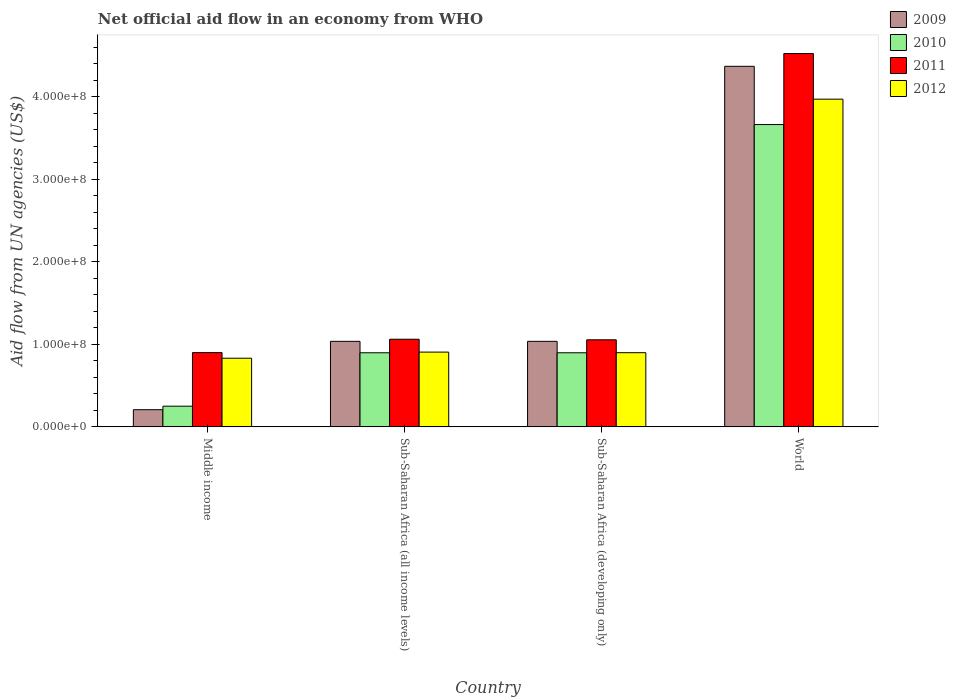How many different coloured bars are there?
Ensure brevity in your answer.  4. How many groups of bars are there?
Offer a terse response. 4. Are the number of bars per tick equal to the number of legend labels?
Provide a short and direct response. Yes. In how many cases, is the number of bars for a given country not equal to the number of legend labels?
Ensure brevity in your answer.  0. What is the net official aid flow in 2011 in Sub-Saharan Africa (developing only)?
Your answer should be compact. 1.05e+08. Across all countries, what is the maximum net official aid flow in 2010?
Your response must be concise. 3.66e+08. Across all countries, what is the minimum net official aid flow in 2011?
Your response must be concise. 9.00e+07. In which country was the net official aid flow in 2009 maximum?
Your response must be concise. World. What is the total net official aid flow in 2011 in the graph?
Make the answer very short. 7.54e+08. What is the difference between the net official aid flow in 2010 in Sub-Saharan Africa (all income levels) and that in World?
Keep it short and to the point. -2.76e+08. What is the difference between the net official aid flow in 2010 in World and the net official aid flow in 2011 in Sub-Saharan Africa (all income levels)?
Your answer should be very brief. 2.60e+08. What is the average net official aid flow in 2011 per country?
Your answer should be compact. 1.88e+08. What is the difference between the net official aid flow of/in 2010 and net official aid flow of/in 2011 in Sub-Saharan Africa (developing only)?
Offer a terse response. -1.57e+07. What is the ratio of the net official aid flow in 2012 in Middle income to that in Sub-Saharan Africa (all income levels)?
Your answer should be compact. 0.92. What is the difference between the highest and the second highest net official aid flow in 2011?
Your response must be concise. 3.47e+08. What is the difference between the highest and the lowest net official aid flow in 2010?
Provide a short and direct response. 3.41e+08. In how many countries, is the net official aid flow in 2011 greater than the average net official aid flow in 2011 taken over all countries?
Your response must be concise. 1. Is it the case that in every country, the sum of the net official aid flow in 2012 and net official aid flow in 2009 is greater than the sum of net official aid flow in 2010 and net official aid flow in 2011?
Ensure brevity in your answer.  No. What does the 4th bar from the left in World represents?
Give a very brief answer. 2012. Is it the case that in every country, the sum of the net official aid flow in 2009 and net official aid flow in 2011 is greater than the net official aid flow in 2010?
Give a very brief answer. Yes. How many countries are there in the graph?
Make the answer very short. 4. Are the values on the major ticks of Y-axis written in scientific E-notation?
Make the answer very short. Yes. Does the graph contain any zero values?
Keep it short and to the point. No. Does the graph contain grids?
Provide a short and direct response. No. Where does the legend appear in the graph?
Your answer should be very brief. Top right. What is the title of the graph?
Offer a terse response. Net official aid flow in an economy from WHO. What is the label or title of the Y-axis?
Provide a succinct answer. Aid flow from UN agencies (US$). What is the Aid flow from UN agencies (US$) in 2009 in Middle income?
Offer a very short reply. 2.08e+07. What is the Aid flow from UN agencies (US$) of 2010 in Middle income?
Offer a very short reply. 2.51e+07. What is the Aid flow from UN agencies (US$) of 2011 in Middle income?
Provide a short and direct response. 9.00e+07. What is the Aid flow from UN agencies (US$) of 2012 in Middle income?
Your answer should be compact. 8.32e+07. What is the Aid flow from UN agencies (US$) in 2009 in Sub-Saharan Africa (all income levels)?
Offer a very short reply. 1.04e+08. What is the Aid flow from UN agencies (US$) in 2010 in Sub-Saharan Africa (all income levels)?
Keep it short and to the point. 8.98e+07. What is the Aid flow from UN agencies (US$) in 2011 in Sub-Saharan Africa (all income levels)?
Provide a short and direct response. 1.06e+08. What is the Aid flow from UN agencies (US$) in 2012 in Sub-Saharan Africa (all income levels)?
Offer a very short reply. 9.06e+07. What is the Aid flow from UN agencies (US$) of 2009 in Sub-Saharan Africa (developing only)?
Provide a short and direct response. 1.04e+08. What is the Aid flow from UN agencies (US$) of 2010 in Sub-Saharan Africa (developing only)?
Your answer should be compact. 8.98e+07. What is the Aid flow from UN agencies (US$) of 2011 in Sub-Saharan Africa (developing only)?
Provide a short and direct response. 1.05e+08. What is the Aid flow from UN agencies (US$) in 2012 in Sub-Saharan Africa (developing only)?
Your response must be concise. 8.98e+07. What is the Aid flow from UN agencies (US$) in 2009 in World?
Your response must be concise. 4.37e+08. What is the Aid flow from UN agencies (US$) in 2010 in World?
Offer a very short reply. 3.66e+08. What is the Aid flow from UN agencies (US$) in 2011 in World?
Keep it short and to the point. 4.52e+08. What is the Aid flow from UN agencies (US$) of 2012 in World?
Give a very brief answer. 3.97e+08. Across all countries, what is the maximum Aid flow from UN agencies (US$) in 2009?
Your answer should be very brief. 4.37e+08. Across all countries, what is the maximum Aid flow from UN agencies (US$) in 2010?
Your response must be concise. 3.66e+08. Across all countries, what is the maximum Aid flow from UN agencies (US$) in 2011?
Your response must be concise. 4.52e+08. Across all countries, what is the maximum Aid flow from UN agencies (US$) in 2012?
Give a very brief answer. 3.97e+08. Across all countries, what is the minimum Aid flow from UN agencies (US$) in 2009?
Provide a succinct answer. 2.08e+07. Across all countries, what is the minimum Aid flow from UN agencies (US$) in 2010?
Keep it short and to the point. 2.51e+07. Across all countries, what is the minimum Aid flow from UN agencies (US$) in 2011?
Ensure brevity in your answer.  9.00e+07. Across all countries, what is the minimum Aid flow from UN agencies (US$) in 2012?
Ensure brevity in your answer.  8.32e+07. What is the total Aid flow from UN agencies (US$) of 2009 in the graph?
Offer a terse response. 6.65e+08. What is the total Aid flow from UN agencies (US$) in 2010 in the graph?
Your answer should be very brief. 5.71e+08. What is the total Aid flow from UN agencies (US$) of 2011 in the graph?
Provide a succinct answer. 7.54e+08. What is the total Aid flow from UN agencies (US$) of 2012 in the graph?
Ensure brevity in your answer.  6.61e+08. What is the difference between the Aid flow from UN agencies (US$) of 2009 in Middle income and that in Sub-Saharan Africa (all income levels)?
Your answer should be compact. -8.28e+07. What is the difference between the Aid flow from UN agencies (US$) of 2010 in Middle income and that in Sub-Saharan Africa (all income levels)?
Offer a terse response. -6.47e+07. What is the difference between the Aid flow from UN agencies (US$) of 2011 in Middle income and that in Sub-Saharan Africa (all income levels)?
Offer a terse response. -1.62e+07. What is the difference between the Aid flow from UN agencies (US$) in 2012 in Middle income and that in Sub-Saharan Africa (all income levels)?
Keep it short and to the point. -7.39e+06. What is the difference between the Aid flow from UN agencies (US$) of 2009 in Middle income and that in Sub-Saharan Africa (developing only)?
Keep it short and to the point. -8.28e+07. What is the difference between the Aid flow from UN agencies (US$) in 2010 in Middle income and that in Sub-Saharan Africa (developing only)?
Offer a very short reply. -6.47e+07. What is the difference between the Aid flow from UN agencies (US$) in 2011 in Middle income and that in Sub-Saharan Africa (developing only)?
Offer a very short reply. -1.55e+07. What is the difference between the Aid flow from UN agencies (US$) of 2012 in Middle income and that in Sub-Saharan Africa (developing only)?
Your response must be concise. -6.67e+06. What is the difference between the Aid flow from UN agencies (US$) in 2009 in Middle income and that in World?
Offer a very short reply. -4.16e+08. What is the difference between the Aid flow from UN agencies (US$) of 2010 in Middle income and that in World?
Your answer should be compact. -3.41e+08. What is the difference between the Aid flow from UN agencies (US$) in 2011 in Middle income and that in World?
Keep it short and to the point. -3.62e+08. What is the difference between the Aid flow from UN agencies (US$) in 2012 in Middle income and that in World?
Your answer should be compact. -3.14e+08. What is the difference between the Aid flow from UN agencies (US$) in 2010 in Sub-Saharan Africa (all income levels) and that in Sub-Saharan Africa (developing only)?
Your answer should be compact. 0. What is the difference between the Aid flow from UN agencies (US$) in 2011 in Sub-Saharan Africa (all income levels) and that in Sub-Saharan Africa (developing only)?
Give a very brief answer. 6.70e+05. What is the difference between the Aid flow from UN agencies (US$) of 2012 in Sub-Saharan Africa (all income levels) and that in Sub-Saharan Africa (developing only)?
Provide a succinct answer. 7.20e+05. What is the difference between the Aid flow from UN agencies (US$) of 2009 in Sub-Saharan Africa (all income levels) and that in World?
Ensure brevity in your answer.  -3.33e+08. What is the difference between the Aid flow from UN agencies (US$) in 2010 in Sub-Saharan Africa (all income levels) and that in World?
Provide a succinct answer. -2.76e+08. What is the difference between the Aid flow from UN agencies (US$) of 2011 in Sub-Saharan Africa (all income levels) and that in World?
Offer a very short reply. -3.46e+08. What is the difference between the Aid flow from UN agencies (US$) in 2012 in Sub-Saharan Africa (all income levels) and that in World?
Offer a terse response. -3.06e+08. What is the difference between the Aid flow from UN agencies (US$) of 2009 in Sub-Saharan Africa (developing only) and that in World?
Your answer should be compact. -3.33e+08. What is the difference between the Aid flow from UN agencies (US$) of 2010 in Sub-Saharan Africa (developing only) and that in World?
Your answer should be very brief. -2.76e+08. What is the difference between the Aid flow from UN agencies (US$) in 2011 in Sub-Saharan Africa (developing only) and that in World?
Your answer should be very brief. -3.47e+08. What is the difference between the Aid flow from UN agencies (US$) of 2012 in Sub-Saharan Africa (developing only) and that in World?
Offer a very short reply. -3.07e+08. What is the difference between the Aid flow from UN agencies (US$) of 2009 in Middle income and the Aid flow from UN agencies (US$) of 2010 in Sub-Saharan Africa (all income levels)?
Your response must be concise. -6.90e+07. What is the difference between the Aid flow from UN agencies (US$) in 2009 in Middle income and the Aid flow from UN agencies (US$) in 2011 in Sub-Saharan Africa (all income levels)?
Ensure brevity in your answer.  -8.54e+07. What is the difference between the Aid flow from UN agencies (US$) of 2009 in Middle income and the Aid flow from UN agencies (US$) of 2012 in Sub-Saharan Africa (all income levels)?
Provide a short and direct response. -6.98e+07. What is the difference between the Aid flow from UN agencies (US$) in 2010 in Middle income and the Aid flow from UN agencies (US$) in 2011 in Sub-Saharan Africa (all income levels)?
Your response must be concise. -8.11e+07. What is the difference between the Aid flow from UN agencies (US$) in 2010 in Middle income and the Aid flow from UN agencies (US$) in 2012 in Sub-Saharan Africa (all income levels)?
Give a very brief answer. -6.55e+07. What is the difference between the Aid flow from UN agencies (US$) in 2011 in Middle income and the Aid flow from UN agencies (US$) in 2012 in Sub-Saharan Africa (all income levels)?
Offer a terse response. -5.90e+05. What is the difference between the Aid flow from UN agencies (US$) of 2009 in Middle income and the Aid flow from UN agencies (US$) of 2010 in Sub-Saharan Africa (developing only)?
Make the answer very short. -6.90e+07. What is the difference between the Aid flow from UN agencies (US$) in 2009 in Middle income and the Aid flow from UN agencies (US$) in 2011 in Sub-Saharan Africa (developing only)?
Offer a very short reply. -8.47e+07. What is the difference between the Aid flow from UN agencies (US$) of 2009 in Middle income and the Aid flow from UN agencies (US$) of 2012 in Sub-Saharan Africa (developing only)?
Provide a succinct answer. -6.90e+07. What is the difference between the Aid flow from UN agencies (US$) in 2010 in Middle income and the Aid flow from UN agencies (US$) in 2011 in Sub-Saharan Africa (developing only)?
Your response must be concise. -8.04e+07. What is the difference between the Aid flow from UN agencies (US$) in 2010 in Middle income and the Aid flow from UN agencies (US$) in 2012 in Sub-Saharan Africa (developing only)?
Your answer should be very brief. -6.48e+07. What is the difference between the Aid flow from UN agencies (US$) in 2011 in Middle income and the Aid flow from UN agencies (US$) in 2012 in Sub-Saharan Africa (developing only)?
Offer a very short reply. 1.30e+05. What is the difference between the Aid flow from UN agencies (US$) of 2009 in Middle income and the Aid flow from UN agencies (US$) of 2010 in World?
Your answer should be very brief. -3.45e+08. What is the difference between the Aid flow from UN agencies (US$) of 2009 in Middle income and the Aid flow from UN agencies (US$) of 2011 in World?
Your answer should be very brief. -4.31e+08. What is the difference between the Aid flow from UN agencies (US$) of 2009 in Middle income and the Aid flow from UN agencies (US$) of 2012 in World?
Ensure brevity in your answer.  -3.76e+08. What is the difference between the Aid flow from UN agencies (US$) in 2010 in Middle income and the Aid flow from UN agencies (US$) in 2011 in World?
Ensure brevity in your answer.  -4.27e+08. What is the difference between the Aid flow from UN agencies (US$) in 2010 in Middle income and the Aid flow from UN agencies (US$) in 2012 in World?
Ensure brevity in your answer.  -3.72e+08. What is the difference between the Aid flow from UN agencies (US$) in 2011 in Middle income and the Aid flow from UN agencies (US$) in 2012 in World?
Offer a very short reply. -3.07e+08. What is the difference between the Aid flow from UN agencies (US$) of 2009 in Sub-Saharan Africa (all income levels) and the Aid flow from UN agencies (US$) of 2010 in Sub-Saharan Africa (developing only)?
Keep it short and to the point. 1.39e+07. What is the difference between the Aid flow from UN agencies (US$) in 2009 in Sub-Saharan Africa (all income levels) and the Aid flow from UN agencies (US$) in 2011 in Sub-Saharan Africa (developing only)?
Provide a short and direct response. -1.86e+06. What is the difference between the Aid flow from UN agencies (US$) in 2009 in Sub-Saharan Africa (all income levels) and the Aid flow from UN agencies (US$) in 2012 in Sub-Saharan Africa (developing only)?
Provide a short and direct response. 1.38e+07. What is the difference between the Aid flow from UN agencies (US$) of 2010 in Sub-Saharan Africa (all income levels) and the Aid flow from UN agencies (US$) of 2011 in Sub-Saharan Africa (developing only)?
Give a very brief answer. -1.57e+07. What is the difference between the Aid flow from UN agencies (US$) in 2011 in Sub-Saharan Africa (all income levels) and the Aid flow from UN agencies (US$) in 2012 in Sub-Saharan Africa (developing only)?
Make the answer very short. 1.63e+07. What is the difference between the Aid flow from UN agencies (US$) of 2009 in Sub-Saharan Africa (all income levels) and the Aid flow from UN agencies (US$) of 2010 in World?
Offer a terse response. -2.63e+08. What is the difference between the Aid flow from UN agencies (US$) in 2009 in Sub-Saharan Africa (all income levels) and the Aid flow from UN agencies (US$) in 2011 in World?
Your answer should be compact. -3.49e+08. What is the difference between the Aid flow from UN agencies (US$) in 2009 in Sub-Saharan Africa (all income levels) and the Aid flow from UN agencies (US$) in 2012 in World?
Offer a terse response. -2.93e+08. What is the difference between the Aid flow from UN agencies (US$) of 2010 in Sub-Saharan Africa (all income levels) and the Aid flow from UN agencies (US$) of 2011 in World?
Make the answer very short. -3.62e+08. What is the difference between the Aid flow from UN agencies (US$) in 2010 in Sub-Saharan Africa (all income levels) and the Aid flow from UN agencies (US$) in 2012 in World?
Make the answer very short. -3.07e+08. What is the difference between the Aid flow from UN agencies (US$) of 2011 in Sub-Saharan Africa (all income levels) and the Aid flow from UN agencies (US$) of 2012 in World?
Give a very brief answer. -2.91e+08. What is the difference between the Aid flow from UN agencies (US$) of 2009 in Sub-Saharan Africa (developing only) and the Aid flow from UN agencies (US$) of 2010 in World?
Offer a very short reply. -2.63e+08. What is the difference between the Aid flow from UN agencies (US$) of 2009 in Sub-Saharan Africa (developing only) and the Aid flow from UN agencies (US$) of 2011 in World?
Give a very brief answer. -3.49e+08. What is the difference between the Aid flow from UN agencies (US$) in 2009 in Sub-Saharan Africa (developing only) and the Aid flow from UN agencies (US$) in 2012 in World?
Your answer should be compact. -2.93e+08. What is the difference between the Aid flow from UN agencies (US$) of 2010 in Sub-Saharan Africa (developing only) and the Aid flow from UN agencies (US$) of 2011 in World?
Offer a very short reply. -3.62e+08. What is the difference between the Aid flow from UN agencies (US$) in 2010 in Sub-Saharan Africa (developing only) and the Aid flow from UN agencies (US$) in 2012 in World?
Your response must be concise. -3.07e+08. What is the difference between the Aid flow from UN agencies (US$) in 2011 in Sub-Saharan Africa (developing only) and the Aid flow from UN agencies (US$) in 2012 in World?
Your answer should be compact. -2.92e+08. What is the average Aid flow from UN agencies (US$) of 2009 per country?
Your answer should be compact. 1.66e+08. What is the average Aid flow from UN agencies (US$) of 2010 per country?
Provide a succinct answer. 1.43e+08. What is the average Aid flow from UN agencies (US$) in 2011 per country?
Provide a succinct answer. 1.88e+08. What is the average Aid flow from UN agencies (US$) of 2012 per country?
Your answer should be very brief. 1.65e+08. What is the difference between the Aid flow from UN agencies (US$) of 2009 and Aid flow from UN agencies (US$) of 2010 in Middle income?
Your answer should be very brief. -4.27e+06. What is the difference between the Aid flow from UN agencies (US$) in 2009 and Aid flow from UN agencies (US$) in 2011 in Middle income?
Provide a succinct answer. -6.92e+07. What is the difference between the Aid flow from UN agencies (US$) of 2009 and Aid flow from UN agencies (US$) of 2012 in Middle income?
Your answer should be compact. -6.24e+07. What is the difference between the Aid flow from UN agencies (US$) in 2010 and Aid flow from UN agencies (US$) in 2011 in Middle income?
Ensure brevity in your answer.  -6.49e+07. What is the difference between the Aid flow from UN agencies (US$) of 2010 and Aid flow from UN agencies (US$) of 2012 in Middle income?
Your answer should be very brief. -5.81e+07. What is the difference between the Aid flow from UN agencies (US$) in 2011 and Aid flow from UN agencies (US$) in 2012 in Middle income?
Provide a short and direct response. 6.80e+06. What is the difference between the Aid flow from UN agencies (US$) of 2009 and Aid flow from UN agencies (US$) of 2010 in Sub-Saharan Africa (all income levels)?
Your answer should be very brief. 1.39e+07. What is the difference between the Aid flow from UN agencies (US$) of 2009 and Aid flow from UN agencies (US$) of 2011 in Sub-Saharan Africa (all income levels)?
Your answer should be compact. -2.53e+06. What is the difference between the Aid flow from UN agencies (US$) in 2009 and Aid flow from UN agencies (US$) in 2012 in Sub-Saharan Africa (all income levels)?
Provide a succinct answer. 1.30e+07. What is the difference between the Aid flow from UN agencies (US$) in 2010 and Aid flow from UN agencies (US$) in 2011 in Sub-Saharan Africa (all income levels)?
Your response must be concise. -1.64e+07. What is the difference between the Aid flow from UN agencies (US$) in 2010 and Aid flow from UN agencies (US$) in 2012 in Sub-Saharan Africa (all income levels)?
Provide a succinct answer. -8.10e+05. What is the difference between the Aid flow from UN agencies (US$) in 2011 and Aid flow from UN agencies (US$) in 2012 in Sub-Saharan Africa (all income levels)?
Provide a succinct answer. 1.56e+07. What is the difference between the Aid flow from UN agencies (US$) in 2009 and Aid flow from UN agencies (US$) in 2010 in Sub-Saharan Africa (developing only)?
Give a very brief answer. 1.39e+07. What is the difference between the Aid flow from UN agencies (US$) of 2009 and Aid flow from UN agencies (US$) of 2011 in Sub-Saharan Africa (developing only)?
Offer a very short reply. -1.86e+06. What is the difference between the Aid flow from UN agencies (US$) of 2009 and Aid flow from UN agencies (US$) of 2012 in Sub-Saharan Africa (developing only)?
Your answer should be very brief. 1.38e+07. What is the difference between the Aid flow from UN agencies (US$) in 2010 and Aid flow from UN agencies (US$) in 2011 in Sub-Saharan Africa (developing only)?
Provide a short and direct response. -1.57e+07. What is the difference between the Aid flow from UN agencies (US$) in 2011 and Aid flow from UN agencies (US$) in 2012 in Sub-Saharan Africa (developing only)?
Ensure brevity in your answer.  1.56e+07. What is the difference between the Aid flow from UN agencies (US$) of 2009 and Aid flow from UN agencies (US$) of 2010 in World?
Give a very brief answer. 7.06e+07. What is the difference between the Aid flow from UN agencies (US$) in 2009 and Aid flow from UN agencies (US$) in 2011 in World?
Your response must be concise. -1.55e+07. What is the difference between the Aid flow from UN agencies (US$) in 2009 and Aid flow from UN agencies (US$) in 2012 in World?
Make the answer very short. 3.98e+07. What is the difference between the Aid flow from UN agencies (US$) in 2010 and Aid flow from UN agencies (US$) in 2011 in World?
Give a very brief answer. -8.60e+07. What is the difference between the Aid flow from UN agencies (US$) of 2010 and Aid flow from UN agencies (US$) of 2012 in World?
Provide a succinct answer. -3.08e+07. What is the difference between the Aid flow from UN agencies (US$) in 2011 and Aid flow from UN agencies (US$) in 2012 in World?
Give a very brief answer. 5.53e+07. What is the ratio of the Aid flow from UN agencies (US$) in 2009 in Middle income to that in Sub-Saharan Africa (all income levels)?
Provide a short and direct response. 0.2. What is the ratio of the Aid flow from UN agencies (US$) in 2010 in Middle income to that in Sub-Saharan Africa (all income levels)?
Give a very brief answer. 0.28. What is the ratio of the Aid flow from UN agencies (US$) in 2011 in Middle income to that in Sub-Saharan Africa (all income levels)?
Give a very brief answer. 0.85. What is the ratio of the Aid flow from UN agencies (US$) in 2012 in Middle income to that in Sub-Saharan Africa (all income levels)?
Offer a terse response. 0.92. What is the ratio of the Aid flow from UN agencies (US$) in 2009 in Middle income to that in Sub-Saharan Africa (developing only)?
Provide a succinct answer. 0.2. What is the ratio of the Aid flow from UN agencies (US$) of 2010 in Middle income to that in Sub-Saharan Africa (developing only)?
Provide a succinct answer. 0.28. What is the ratio of the Aid flow from UN agencies (US$) in 2011 in Middle income to that in Sub-Saharan Africa (developing only)?
Ensure brevity in your answer.  0.85. What is the ratio of the Aid flow from UN agencies (US$) of 2012 in Middle income to that in Sub-Saharan Africa (developing only)?
Provide a succinct answer. 0.93. What is the ratio of the Aid flow from UN agencies (US$) of 2009 in Middle income to that in World?
Your answer should be compact. 0.05. What is the ratio of the Aid flow from UN agencies (US$) in 2010 in Middle income to that in World?
Give a very brief answer. 0.07. What is the ratio of the Aid flow from UN agencies (US$) in 2011 in Middle income to that in World?
Your answer should be very brief. 0.2. What is the ratio of the Aid flow from UN agencies (US$) in 2012 in Middle income to that in World?
Offer a terse response. 0.21. What is the ratio of the Aid flow from UN agencies (US$) in 2011 in Sub-Saharan Africa (all income levels) to that in Sub-Saharan Africa (developing only)?
Offer a very short reply. 1.01. What is the ratio of the Aid flow from UN agencies (US$) in 2012 in Sub-Saharan Africa (all income levels) to that in Sub-Saharan Africa (developing only)?
Provide a short and direct response. 1.01. What is the ratio of the Aid flow from UN agencies (US$) of 2009 in Sub-Saharan Africa (all income levels) to that in World?
Your answer should be very brief. 0.24. What is the ratio of the Aid flow from UN agencies (US$) in 2010 in Sub-Saharan Africa (all income levels) to that in World?
Your answer should be very brief. 0.25. What is the ratio of the Aid flow from UN agencies (US$) of 2011 in Sub-Saharan Africa (all income levels) to that in World?
Provide a short and direct response. 0.23. What is the ratio of the Aid flow from UN agencies (US$) in 2012 in Sub-Saharan Africa (all income levels) to that in World?
Ensure brevity in your answer.  0.23. What is the ratio of the Aid flow from UN agencies (US$) in 2009 in Sub-Saharan Africa (developing only) to that in World?
Your answer should be compact. 0.24. What is the ratio of the Aid flow from UN agencies (US$) of 2010 in Sub-Saharan Africa (developing only) to that in World?
Make the answer very short. 0.25. What is the ratio of the Aid flow from UN agencies (US$) in 2011 in Sub-Saharan Africa (developing only) to that in World?
Offer a terse response. 0.23. What is the ratio of the Aid flow from UN agencies (US$) in 2012 in Sub-Saharan Africa (developing only) to that in World?
Offer a very short reply. 0.23. What is the difference between the highest and the second highest Aid flow from UN agencies (US$) of 2009?
Provide a short and direct response. 3.33e+08. What is the difference between the highest and the second highest Aid flow from UN agencies (US$) in 2010?
Your answer should be compact. 2.76e+08. What is the difference between the highest and the second highest Aid flow from UN agencies (US$) of 2011?
Make the answer very short. 3.46e+08. What is the difference between the highest and the second highest Aid flow from UN agencies (US$) in 2012?
Your answer should be compact. 3.06e+08. What is the difference between the highest and the lowest Aid flow from UN agencies (US$) in 2009?
Your answer should be very brief. 4.16e+08. What is the difference between the highest and the lowest Aid flow from UN agencies (US$) of 2010?
Provide a succinct answer. 3.41e+08. What is the difference between the highest and the lowest Aid flow from UN agencies (US$) in 2011?
Keep it short and to the point. 3.62e+08. What is the difference between the highest and the lowest Aid flow from UN agencies (US$) in 2012?
Offer a very short reply. 3.14e+08. 